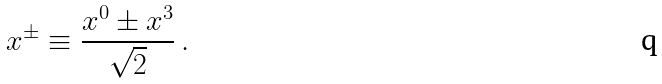Convert formula to latex. <formula><loc_0><loc_0><loc_500><loc_500>x ^ { \pm } \equiv \frac { x ^ { 0 } \pm x ^ { 3 } } { \sqrt { 2 } } \, .</formula> 